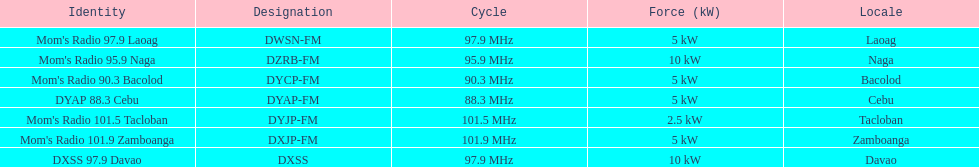What is the difference in kw between naga and bacolod radio? 5 kW. 